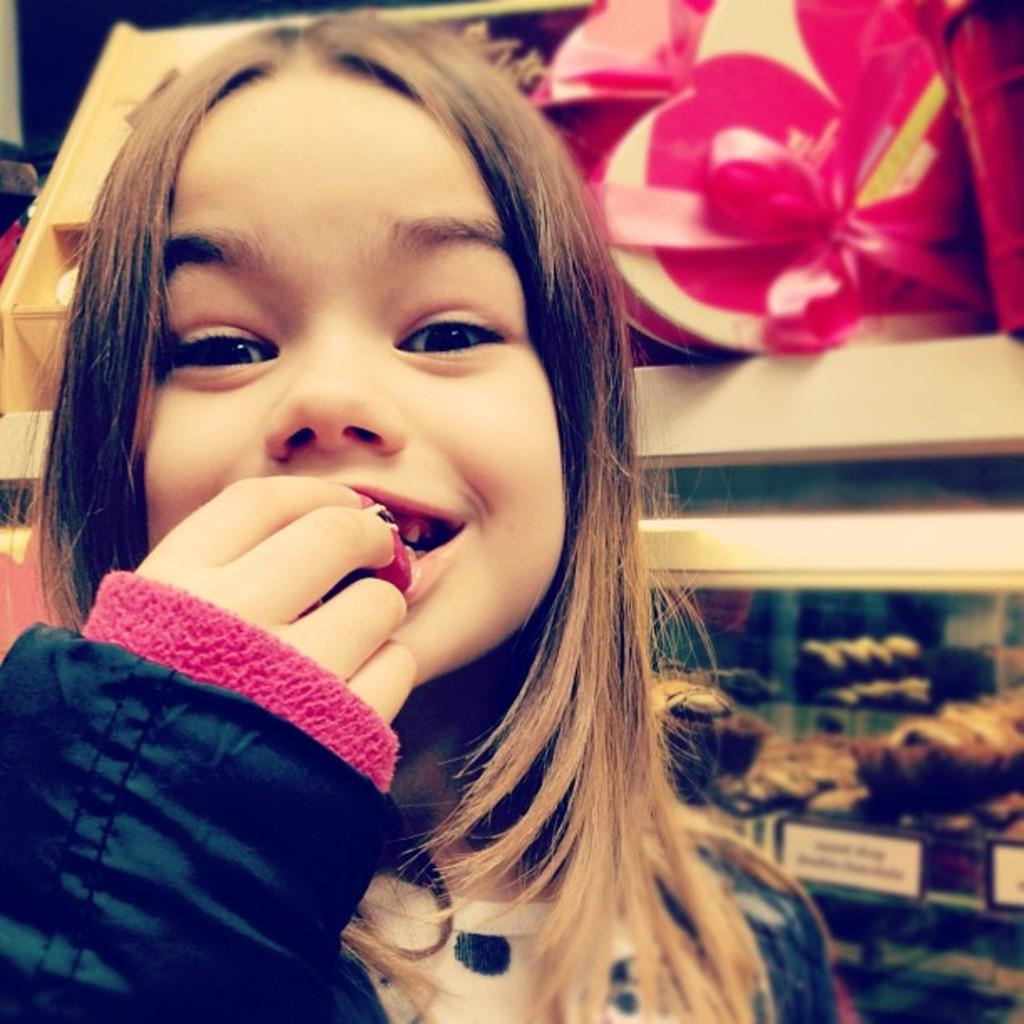What is the main subject of the image? There is a kid in the image. What is the kid doing in the image? The kid is eating a food item. On which side of the image is the kid located? The kid is on the left side of the image. What can be seen in the background of the image? There are objects in the racks in the background of the image. What type of tax is being discussed in the image? There is no discussion of tax in the image; it features a kid eating a food item. Can you tell me how many toads are present in the image? There are no toads present in the image. 